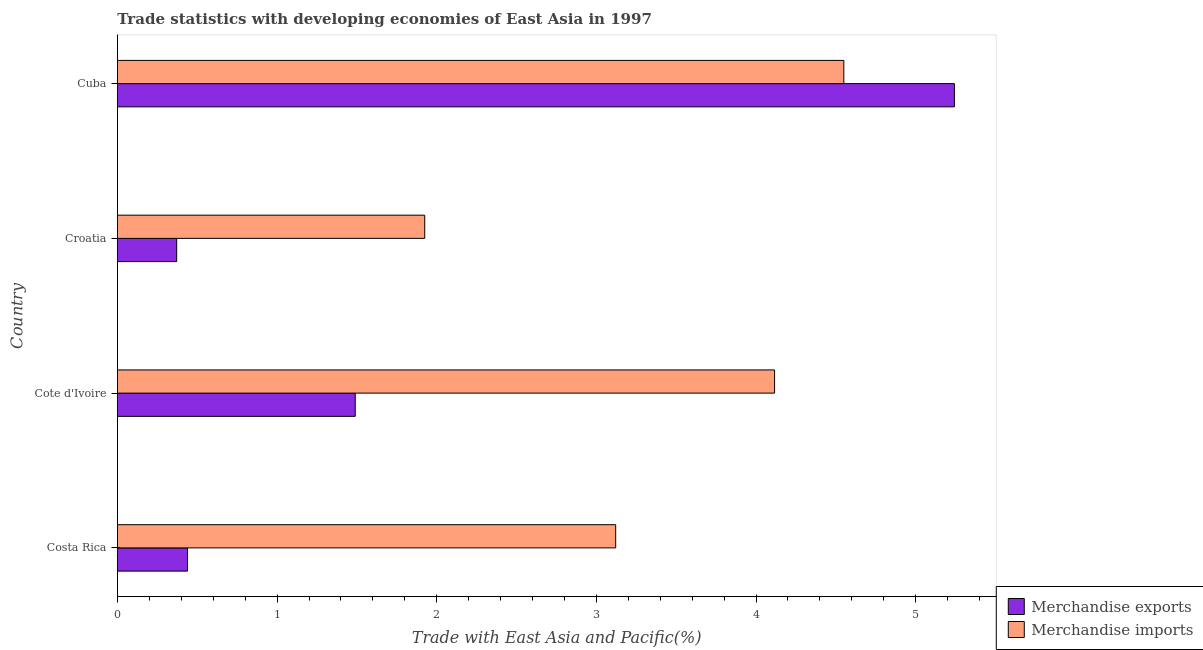How many different coloured bars are there?
Keep it short and to the point. 2. Are the number of bars per tick equal to the number of legend labels?
Your answer should be compact. Yes. How many bars are there on the 3rd tick from the bottom?
Provide a succinct answer. 2. What is the label of the 3rd group of bars from the top?
Your answer should be very brief. Cote d'Ivoire. What is the merchandise exports in Croatia?
Provide a succinct answer. 0.37. Across all countries, what is the maximum merchandise exports?
Your answer should be compact. 5.24. Across all countries, what is the minimum merchandise exports?
Your answer should be very brief. 0.37. In which country was the merchandise exports maximum?
Your answer should be very brief. Cuba. In which country was the merchandise imports minimum?
Keep it short and to the point. Croatia. What is the total merchandise imports in the graph?
Keep it short and to the point. 13.71. What is the difference between the merchandise exports in Cote d'Ivoire and that in Croatia?
Your response must be concise. 1.12. What is the difference between the merchandise exports in Costa Rica and the merchandise imports in Cote d'Ivoire?
Offer a terse response. -3.68. What is the average merchandise exports per country?
Make the answer very short. 1.89. What is the difference between the merchandise exports and merchandise imports in Costa Rica?
Make the answer very short. -2.68. What is the ratio of the merchandise exports in Cote d'Ivoire to that in Cuba?
Provide a succinct answer. 0.28. Is the merchandise exports in Costa Rica less than that in Cote d'Ivoire?
Your answer should be very brief. Yes. What is the difference between the highest and the second highest merchandise exports?
Your response must be concise. 3.75. What is the difference between the highest and the lowest merchandise imports?
Your answer should be compact. 2.63. In how many countries, is the merchandise exports greater than the average merchandise exports taken over all countries?
Give a very brief answer. 1. Are all the bars in the graph horizontal?
Your answer should be compact. Yes. Are the values on the major ticks of X-axis written in scientific E-notation?
Make the answer very short. No. Where does the legend appear in the graph?
Offer a very short reply. Bottom right. What is the title of the graph?
Give a very brief answer. Trade statistics with developing economies of East Asia in 1997. What is the label or title of the X-axis?
Your answer should be compact. Trade with East Asia and Pacific(%). What is the label or title of the Y-axis?
Give a very brief answer. Country. What is the Trade with East Asia and Pacific(%) of Merchandise exports in Costa Rica?
Ensure brevity in your answer.  0.44. What is the Trade with East Asia and Pacific(%) of Merchandise imports in Costa Rica?
Ensure brevity in your answer.  3.12. What is the Trade with East Asia and Pacific(%) of Merchandise exports in Cote d'Ivoire?
Give a very brief answer. 1.49. What is the Trade with East Asia and Pacific(%) in Merchandise imports in Cote d'Ivoire?
Provide a succinct answer. 4.12. What is the Trade with East Asia and Pacific(%) of Merchandise exports in Croatia?
Your answer should be compact. 0.37. What is the Trade with East Asia and Pacific(%) of Merchandise imports in Croatia?
Your answer should be very brief. 1.92. What is the Trade with East Asia and Pacific(%) in Merchandise exports in Cuba?
Your answer should be very brief. 5.24. What is the Trade with East Asia and Pacific(%) of Merchandise imports in Cuba?
Your response must be concise. 4.55. Across all countries, what is the maximum Trade with East Asia and Pacific(%) in Merchandise exports?
Your answer should be compact. 5.24. Across all countries, what is the maximum Trade with East Asia and Pacific(%) of Merchandise imports?
Offer a very short reply. 4.55. Across all countries, what is the minimum Trade with East Asia and Pacific(%) of Merchandise exports?
Provide a succinct answer. 0.37. Across all countries, what is the minimum Trade with East Asia and Pacific(%) of Merchandise imports?
Your answer should be very brief. 1.92. What is the total Trade with East Asia and Pacific(%) of Merchandise exports in the graph?
Provide a short and direct response. 7.54. What is the total Trade with East Asia and Pacific(%) in Merchandise imports in the graph?
Offer a terse response. 13.71. What is the difference between the Trade with East Asia and Pacific(%) of Merchandise exports in Costa Rica and that in Cote d'Ivoire?
Offer a very short reply. -1.05. What is the difference between the Trade with East Asia and Pacific(%) in Merchandise imports in Costa Rica and that in Cote d'Ivoire?
Make the answer very short. -1. What is the difference between the Trade with East Asia and Pacific(%) in Merchandise exports in Costa Rica and that in Croatia?
Provide a short and direct response. 0.07. What is the difference between the Trade with East Asia and Pacific(%) in Merchandise imports in Costa Rica and that in Croatia?
Make the answer very short. 1.2. What is the difference between the Trade with East Asia and Pacific(%) in Merchandise exports in Costa Rica and that in Cuba?
Give a very brief answer. -4.8. What is the difference between the Trade with East Asia and Pacific(%) in Merchandise imports in Costa Rica and that in Cuba?
Ensure brevity in your answer.  -1.43. What is the difference between the Trade with East Asia and Pacific(%) in Merchandise exports in Cote d'Ivoire and that in Croatia?
Provide a succinct answer. 1.12. What is the difference between the Trade with East Asia and Pacific(%) of Merchandise imports in Cote d'Ivoire and that in Croatia?
Offer a terse response. 2.19. What is the difference between the Trade with East Asia and Pacific(%) in Merchandise exports in Cote d'Ivoire and that in Cuba?
Ensure brevity in your answer.  -3.75. What is the difference between the Trade with East Asia and Pacific(%) of Merchandise imports in Cote d'Ivoire and that in Cuba?
Your response must be concise. -0.43. What is the difference between the Trade with East Asia and Pacific(%) in Merchandise exports in Croatia and that in Cuba?
Ensure brevity in your answer.  -4.87. What is the difference between the Trade with East Asia and Pacific(%) in Merchandise imports in Croatia and that in Cuba?
Provide a short and direct response. -2.63. What is the difference between the Trade with East Asia and Pacific(%) of Merchandise exports in Costa Rica and the Trade with East Asia and Pacific(%) of Merchandise imports in Cote d'Ivoire?
Give a very brief answer. -3.68. What is the difference between the Trade with East Asia and Pacific(%) of Merchandise exports in Costa Rica and the Trade with East Asia and Pacific(%) of Merchandise imports in Croatia?
Keep it short and to the point. -1.49. What is the difference between the Trade with East Asia and Pacific(%) in Merchandise exports in Costa Rica and the Trade with East Asia and Pacific(%) in Merchandise imports in Cuba?
Your answer should be compact. -4.11. What is the difference between the Trade with East Asia and Pacific(%) of Merchandise exports in Cote d'Ivoire and the Trade with East Asia and Pacific(%) of Merchandise imports in Croatia?
Your response must be concise. -0.44. What is the difference between the Trade with East Asia and Pacific(%) of Merchandise exports in Cote d'Ivoire and the Trade with East Asia and Pacific(%) of Merchandise imports in Cuba?
Provide a short and direct response. -3.06. What is the difference between the Trade with East Asia and Pacific(%) in Merchandise exports in Croatia and the Trade with East Asia and Pacific(%) in Merchandise imports in Cuba?
Offer a terse response. -4.18. What is the average Trade with East Asia and Pacific(%) of Merchandise exports per country?
Make the answer very short. 1.89. What is the average Trade with East Asia and Pacific(%) of Merchandise imports per country?
Keep it short and to the point. 3.43. What is the difference between the Trade with East Asia and Pacific(%) of Merchandise exports and Trade with East Asia and Pacific(%) of Merchandise imports in Costa Rica?
Offer a very short reply. -2.68. What is the difference between the Trade with East Asia and Pacific(%) of Merchandise exports and Trade with East Asia and Pacific(%) of Merchandise imports in Cote d'Ivoire?
Provide a succinct answer. -2.63. What is the difference between the Trade with East Asia and Pacific(%) of Merchandise exports and Trade with East Asia and Pacific(%) of Merchandise imports in Croatia?
Provide a succinct answer. -1.55. What is the difference between the Trade with East Asia and Pacific(%) in Merchandise exports and Trade with East Asia and Pacific(%) in Merchandise imports in Cuba?
Provide a short and direct response. 0.69. What is the ratio of the Trade with East Asia and Pacific(%) of Merchandise exports in Costa Rica to that in Cote d'Ivoire?
Make the answer very short. 0.29. What is the ratio of the Trade with East Asia and Pacific(%) in Merchandise imports in Costa Rica to that in Cote d'Ivoire?
Provide a succinct answer. 0.76. What is the ratio of the Trade with East Asia and Pacific(%) of Merchandise exports in Costa Rica to that in Croatia?
Ensure brevity in your answer.  1.18. What is the ratio of the Trade with East Asia and Pacific(%) in Merchandise imports in Costa Rica to that in Croatia?
Your answer should be compact. 1.62. What is the ratio of the Trade with East Asia and Pacific(%) in Merchandise exports in Costa Rica to that in Cuba?
Ensure brevity in your answer.  0.08. What is the ratio of the Trade with East Asia and Pacific(%) of Merchandise imports in Costa Rica to that in Cuba?
Your answer should be very brief. 0.69. What is the ratio of the Trade with East Asia and Pacific(%) in Merchandise exports in Cote d'Ivoire to that in Croatia?
Keep it short and to the point. 4.01. What is the ratio of the Trade with East Asia and Pacific(%) of Merchandise imports in Cote d'Ivoire to that in Croatia?
Make the answer very short. 2.14. What is the ratio of the Trade with East Asia and Pacific(%) of Merchandise exports in Cote d'Ivoire to that in Cuba?
Provide a succinct answer. 0.28. What is the ratio of the Trade with East Asia and Pacific(%) in Merchandise imports in Cote d'Ivoire to that in Cuba?
Ensure brevity in your answer.  0.9. What is the ratio of the Trade with East Asia and Pacific(%) of Merchandise exports in Croatia to that in Cuba?
Offer a terse response. 0.07. What is the ratio of the Trade with East Asia and Pacific(%) of Merchandise imports in Croatia to that in Cuba?
Provide a short and direct response. 0.42. What is the difference between the highest and the second highest Trade with East Asia and Pacific(%) of Merchandise exports?
Offer a very short reply. 3.75. What is the difference between the highest and the second highest Trade with East Asia and Pacific(%) of Merchandise imports?
Make the answer very short. 0.43. What is the difference between the highest and the lowest Trade with East Asia and Pacific(%) in Merchandise exports?
Provide a succinct answer. 4.87. What is the difference between the highest and the lowest Trade with East Asia and Pacific(%) in Merchandise imports?
Offer a very short reply. 2.63. 